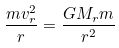Convert formula to latex. <formula><loc_0><loc_0><loc_500><loc_500>\frac { m v _ { r } ^ { 2 } } { r } = \frac { G M _ { r } m } { r ^ { 2 } }</formula> 